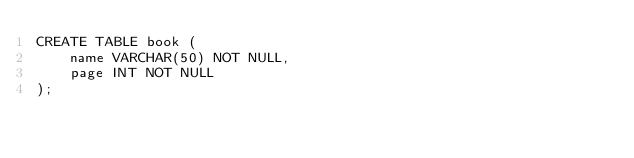<code> <loc_0><loc_0><loc_500><loc_500><_SQL_>CREATE TABLE book (
    name VARCHAR(50) NOT NULL,
    page INT NOT NULL
);</code> 